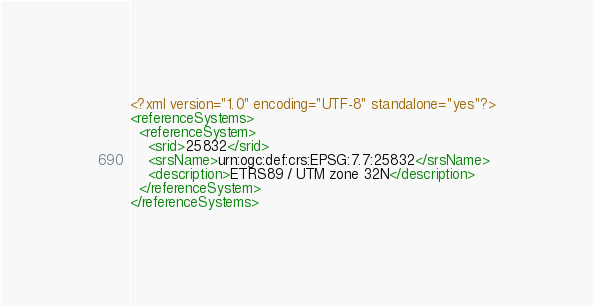Convert code to text. <code><loc_0><loc_0><loc_500><loc_500><_XML_><?xml version="1.0" encoding="UTF-8" standalone="yes"?>
<referenceSystems>
  <referenceSystem>
    <srid>25832</srid>
    <srsName>urn:ogc:def:crs:EPSG:7.7:25832</srsName>
    <description>ETRS89 / UTM zone 32N</description>
  </referenceSystem>
</referenceSystems>
</code> 